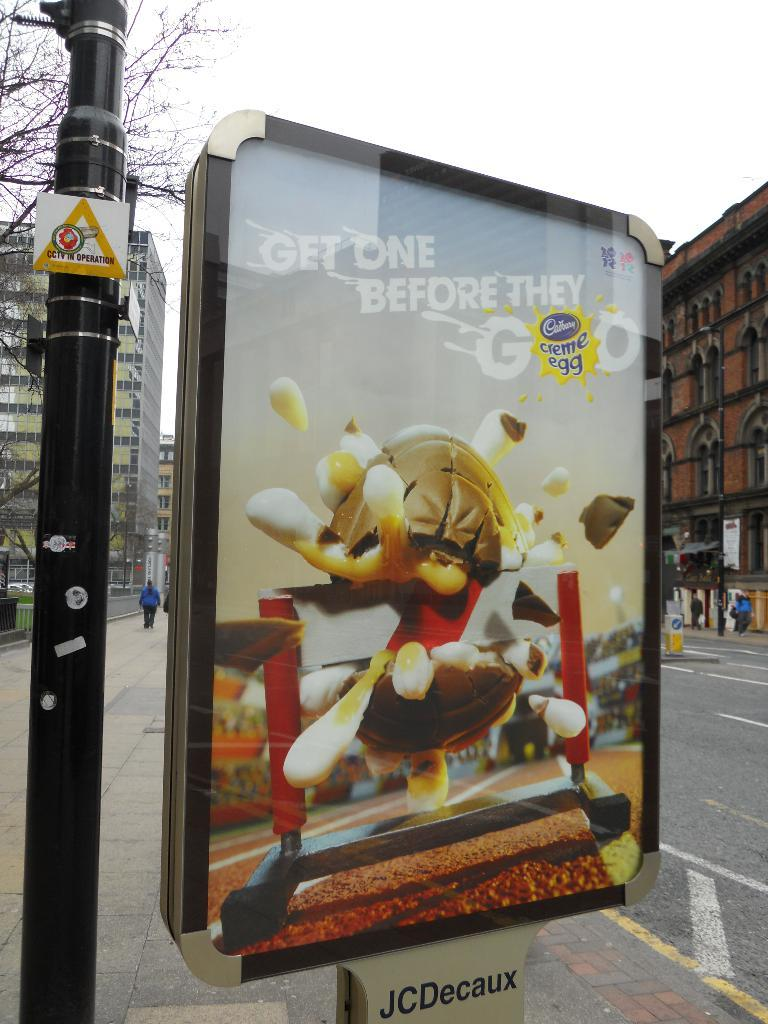<image>
Describe the image concisely. An outdoor advertisement for Cadberry creme eggs with depiction of a creme egg exploding through a runners hurdle. 